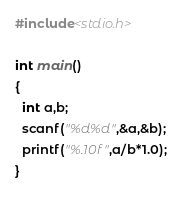<code> <loc_0><loc_0><loc_500><loc_500><_C_>#include<stdio.h>

int main()
{
  int a,b;
  scanf("%d%d",&a,&b);
  printf("%.10f",a/b*1.0);
}</code> 